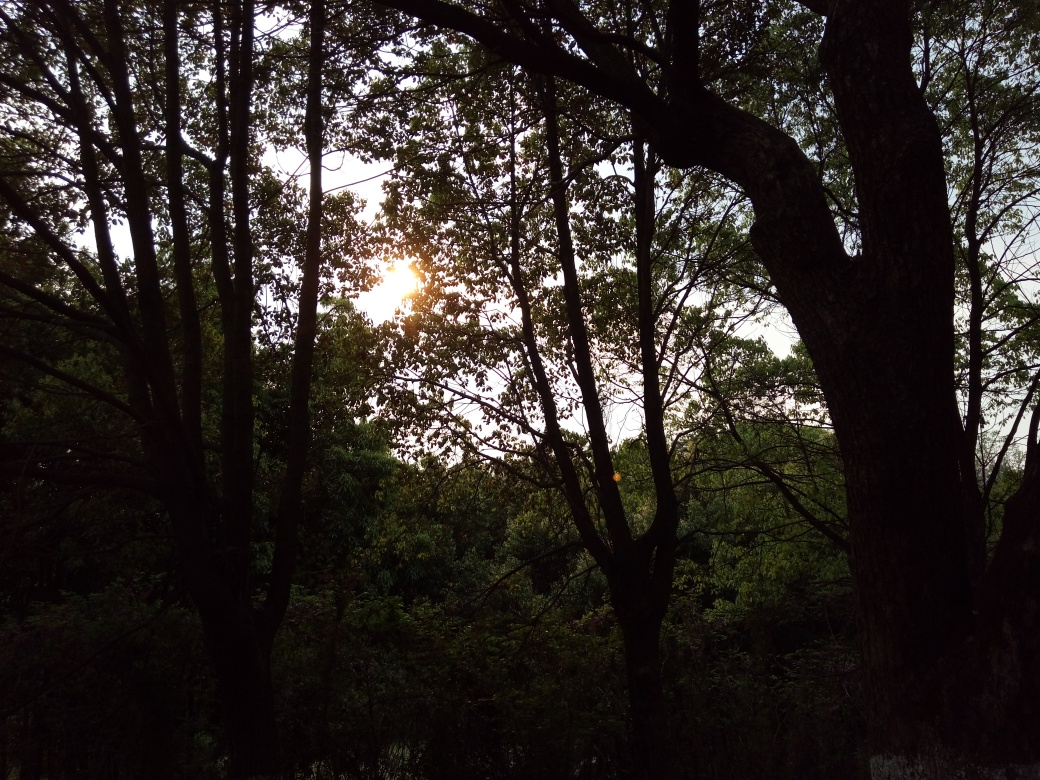What are the issues with the lighting conditions in this image? The image suffers from strong backlighting caused by the sun positioned almost directly in line with the viewpoint, which results in the foreground being significantly underexposed. This underexposure leads to the trees appearing mostly as silhouettes with little to no detail visible, reducing the visual depth and texture. Moreover, the brightness of the sun creates a small glare, which further diminishes the clarity of surrounding elements. The composition, while interesting, lacks balanced lighting, which would help in showcasing more details of the forest environment. 